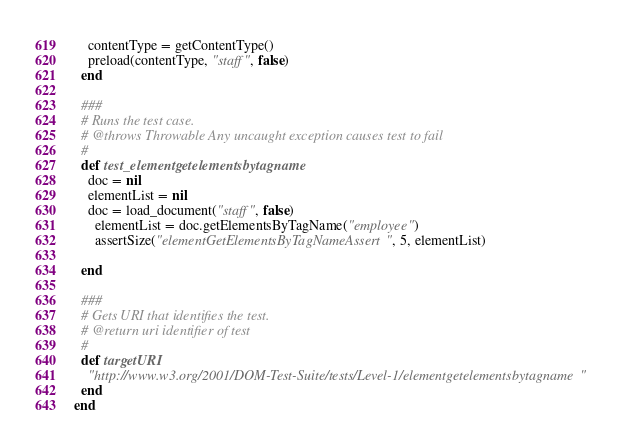Convert code to text. <code><loc_0><loc_0><loc_500><loc_500><_Ruby_>    contentType = getContentType()
    preload(contentType, "staff", false)
  end

  ###
  # Runs the test case.
  # @throws Throwable Any uncaught exception causes test to fail
  #
  def test_elementgetelementsbytagname
    doc = nil
    elementList = nil
    doc = load_document("staff", false)
      elementList = doc.getElementsByTagName("employee")
      assertSize("elementGetElementsByTagNameAssert", 5, elementList)
      
  end

  ###
  # Gets URI that identifies the test.
  # @return uri identifier of test
  #
  def targetURI
    "http://www.w3.org/2001/DOM-Test-Suite/tests/Level-1/elementgetelementsbytagname"
  end
end

</code> 